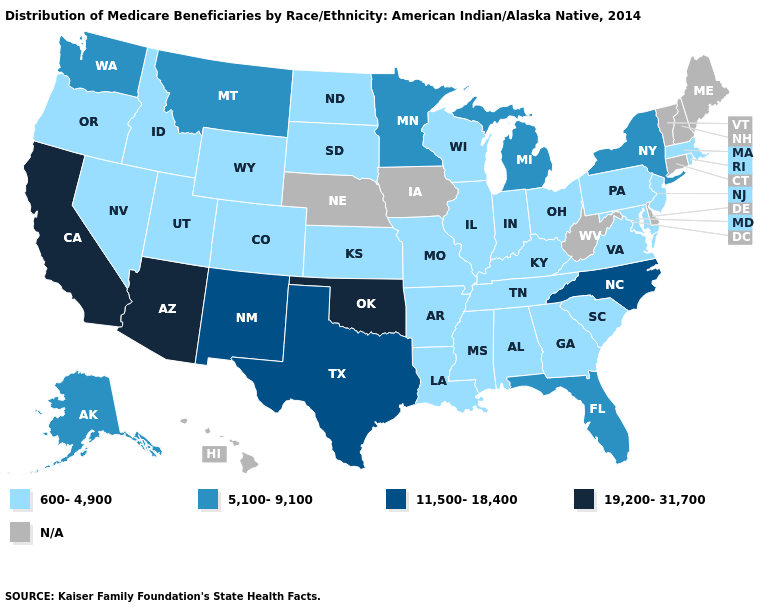Name the states that have a value in the range 600-4,900?
Keep it brief. Alabama, Arkansas, Colorado, Georgia, Idaho, Illinois, Indiana, Kansas, Kentucky, Louisiana, Maryland, Massachusetts, Mississippi, Missouri, Nevada, New Jersey, North Dakota, Ohio, Oregon, Pennsylvania, Rhode Island, South Carolina, South Dakota, Tennessee, Utah, Virginia, Wisconsin, Wyoming. What is the highest value in the South ?
Keep it brief. 19,200-31,700. Does South Dakota have the highest value in the USA?
Be succinct. No. What is the lowest value in the USA?
Write a very short answer. 600-4,900. Which states have the lowest value in the USA?
Write a very short answer. Alabama, Arkansas, Colorado, Georgia, Idaho, Illinois, Indiana, Kansas, Kentucky, Louisiana, Maryland, Massachusetts, Mississippi, Missouri, Nevada, New Jersey, North Dakota, Ohio, Oregon, Pennsylvania, Rhode Island, South Carolina, South Dakota, Tennessee, Utah, Virginia, Wisconsin, Wyoming. What is the value of Vermont?
Short answer required. N/A. Which states have the highest value in the USA?
Answer briefly. Arizona, California, Oklahoma. Which states hav the highest value in the West?
Give a very brief answer. Arizona, California. What is the highest value in states that border South Carolina?
Answer briefly. 11,500-18,400. Name the states that have a value in the range 5,100-9,100?
Short answer required. Alaska, Florida, Michigan, Minnesota, Montana, New York, Washington. Name the states that have a value in the range 19,200-31,700?
Answer briefly. Arizona, California, Oklahoma. Which states have the lowest value in the USA?
Short answer required. Alabama, Arkansas, Colorado, Georgia, Idaho, Illinois, Indiana, Kansas, Kentucky, Louisiana, Maryland, Massachusetts, Mississippi, Missouri, Nevada, New Jersey, North Dakota, Ohio, Oregon, Pennsylvania, Rhode Island, South Carolina, South Dakota, Tennessee, Utah, Virginia, Wisconsin, Wyoming. What is the value of New Mexico?
Write a very short answer. 11,500-18,400. 